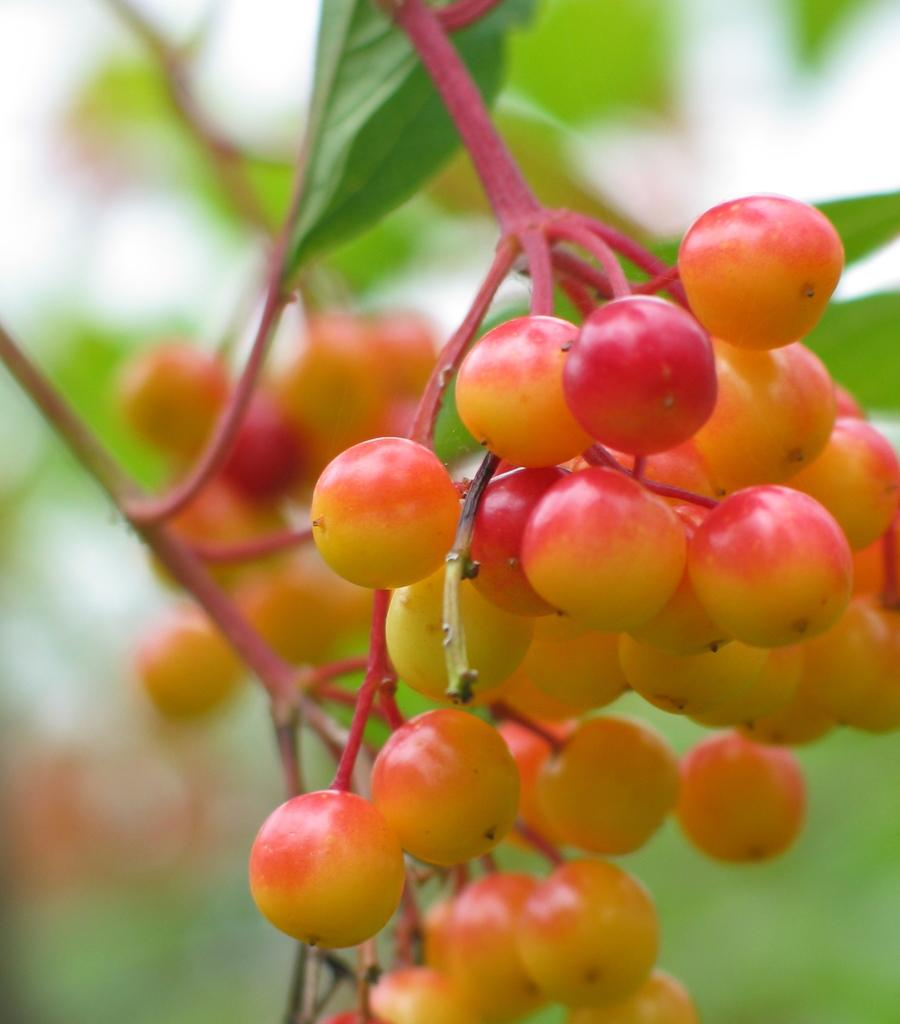What type of fruits are present in the image? There are seedless fruits in the image. Can you describe the background of the image? The background of the image is blurred. What type of lead can be seen in the image? There is no lead present in the image. What color is the ink used in the image? There is no ink present in the image. 